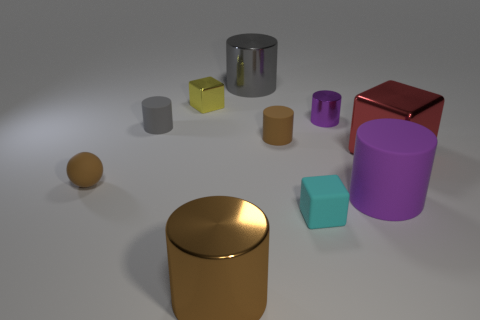Subtract 1 cylinders. How many cylinders are left? 5 Subtract all brown shiny cylinders. How many cylinders are left? 5 Subtract all blue cubes. Subtract all green spheres. How many cubes are left? 3 Subtract all cylinders. How many objects are left? 4 Subtract all tiny green cubes. Subtract all big gray objects. How many objects are left? 9 Add 1 big red shiny things. How many big red shiny things are left? 2 Add 1 big brown matte spheres. How many big brown matte spheres exist? 1 Subtract 0 blue cylinders. How many objects are left? 10 